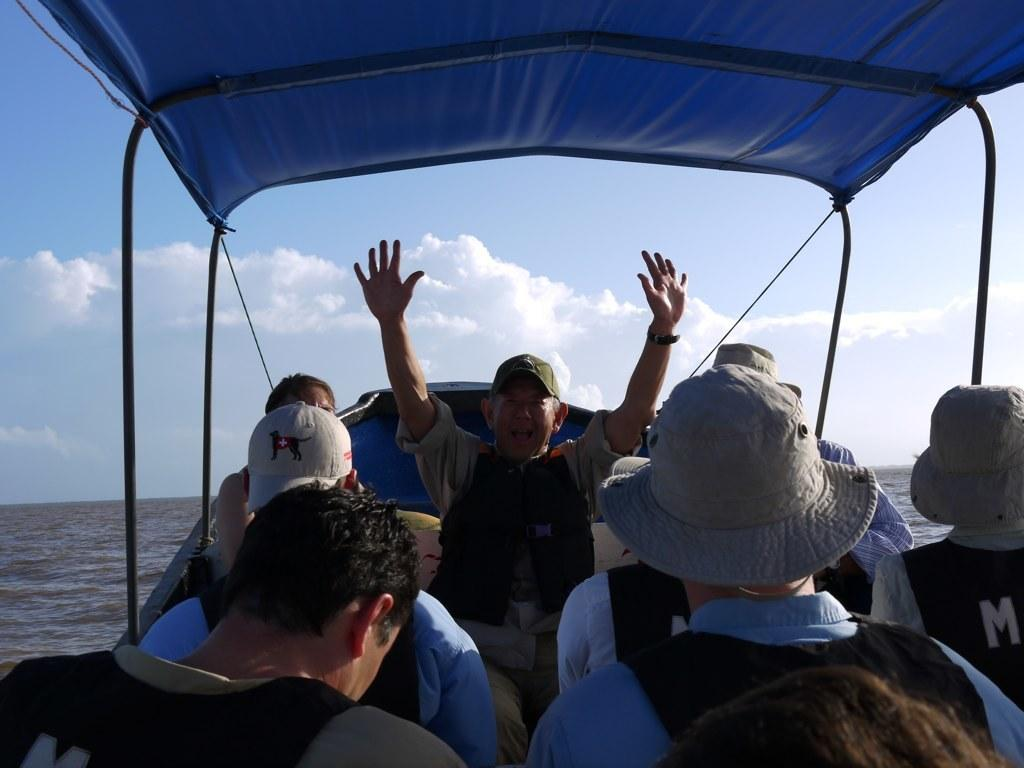What is the main subject of the image? The main subject of the image is a boat. How many people are in the boat? There are multiple people in the boat. What is one person in the boat doing? One person is raising their hands. What can be seen at the top of the image? The sky is visible at the top of the image. What is present on both sides of the image? There is water on both the left and right sides of the image. What type of soup is being served in the boat? There is no soup present in the image; it features a boat with people on the water. Is there a brake system visible in the boat? There is no brake system visible in the boat; it is a recreational vessel on the water. 